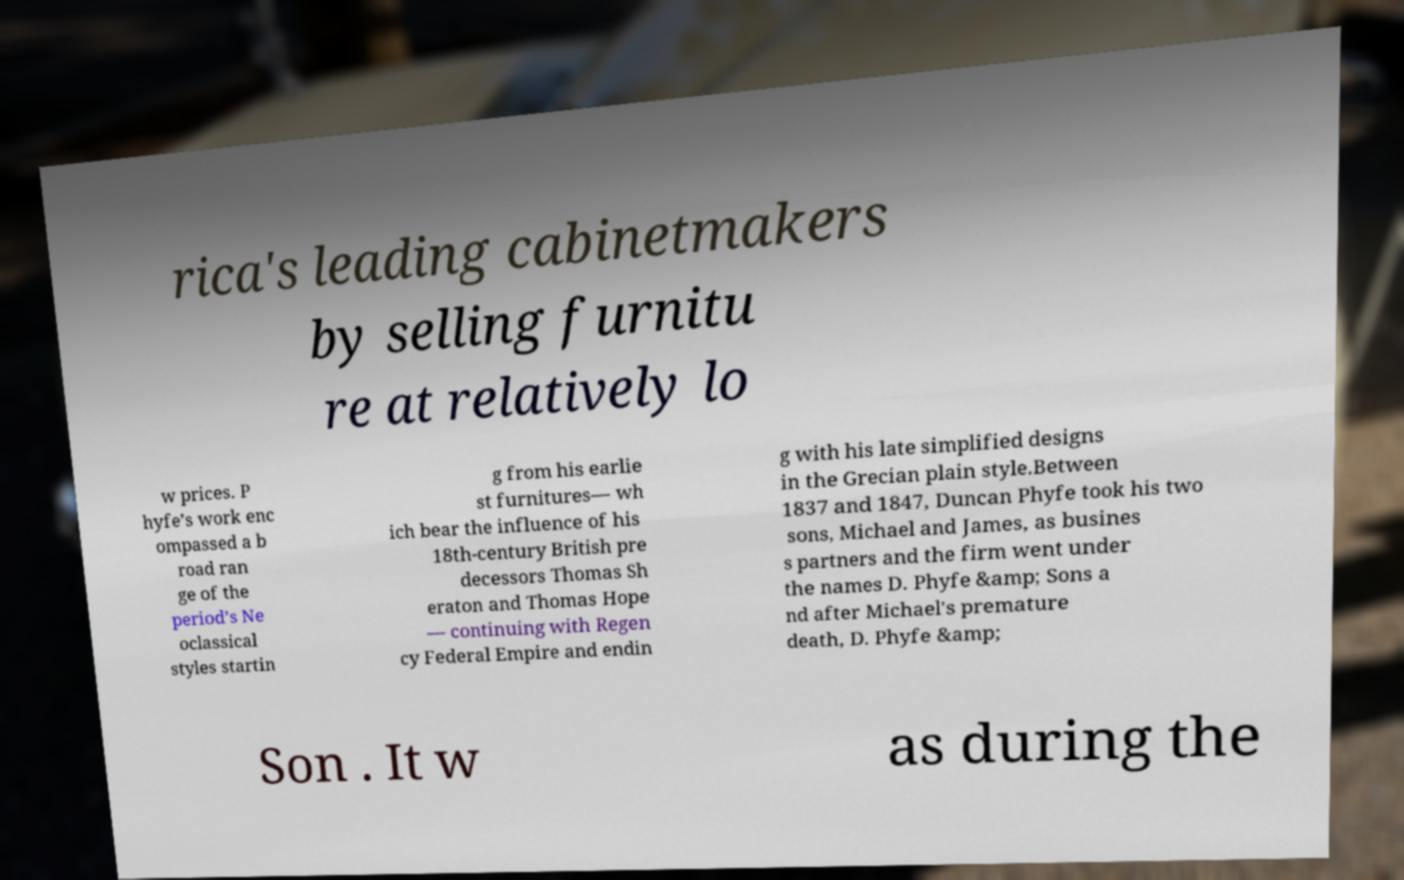There's text embedded in this image that I need extracted. Can you transcribe it verbatim? rica's leading cabinetmakers by selling furnitu re at relatively lo w prices. P hyfe’s work enc ompassed a b road ran ge of the period’s Ne oclassical styles startin g from his earlie st furnitures— wh ich bear the influence of his 18th-century British pre decessors Thomas Sh eraton and Thomas Hope — continuing with Regen cy Federal Empire and endin g with his late simplified designs in the Grecian plain style.Between 1837 and 1847, Duncan Phyfe took his two sons, Michael and James, as busines s partners and the firm went under the names D. Phyfe &amp; Sons a nd after Michael's premature death, D. Phyfe &amp; Son . It w as during the 